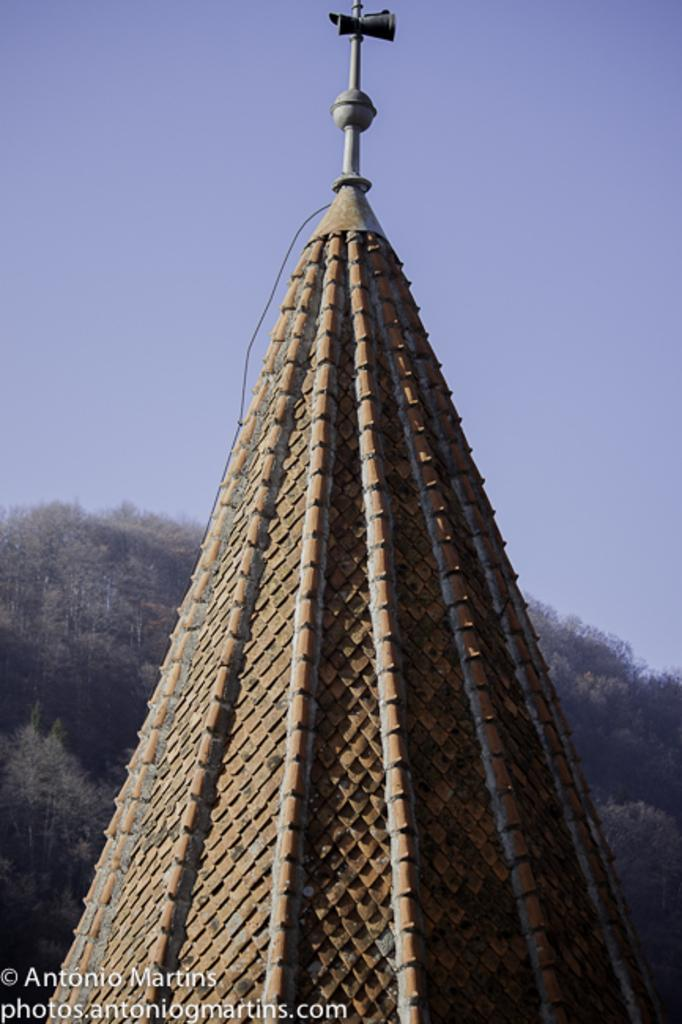What type of structure is depicted in the image? There is an architecture in the image. What can be seen in the background of the image? There are trees and the sky visible in the background of the image. How does the architecture join the farmer in the ploughing process in the image? The image does not depict a farmer or a ploughing process, and the architecture is not shown to be interacting with any such elements. 